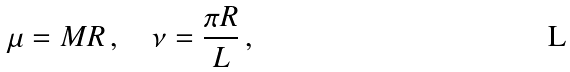Convert formula to latex. <formula><loc_0><loc_0><loc_500><loc_500>\mu = M R \, , \quad \nu = \frac { \pi R } { L } \, ,</formula> 